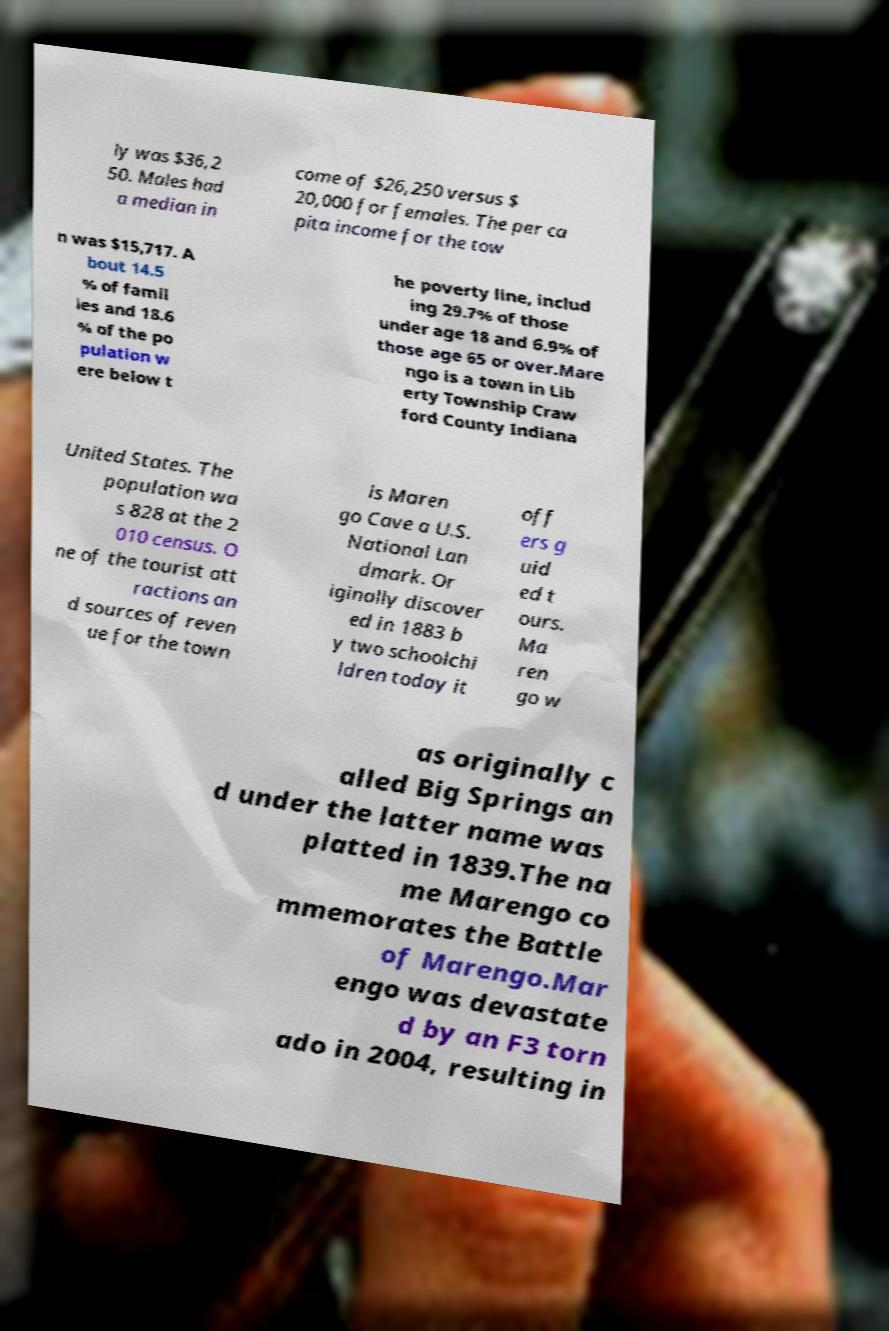There's text embedded in this image that I need extracted. Can you transcribe it verbatim? ly was $36,2 50. Males had a median in come of $26,250 versus $ 20,000 for females. The per ca pita income for the tow n was $15,717. A bout 14.5 % of famil ies and 18.6 % of the po pulation w ere below t he poverty line, includ ing 29.7% of those under age 18 and 6.9% of those age 65 or over.Mare ngo is a town in Lib erty Township Craw ford County Indiana United States. The population wa s 828 at the 2 010 census. O ne of the tourist att ractions an d sources of reven ue for the town is Maren go Cave a U.S. National Lan dmark. Or iginally discover ed in 1883 b y two schoolchi ldren today it off ers g uid ed t ours. Ma ren go w as originally c alled Big Springs an d under the latter name was platted in 1839.The na me Marengo co mmemorates the Battle of Marengo.Mar engo was devastate d by an F3 torn ado in 2004, resulting in 